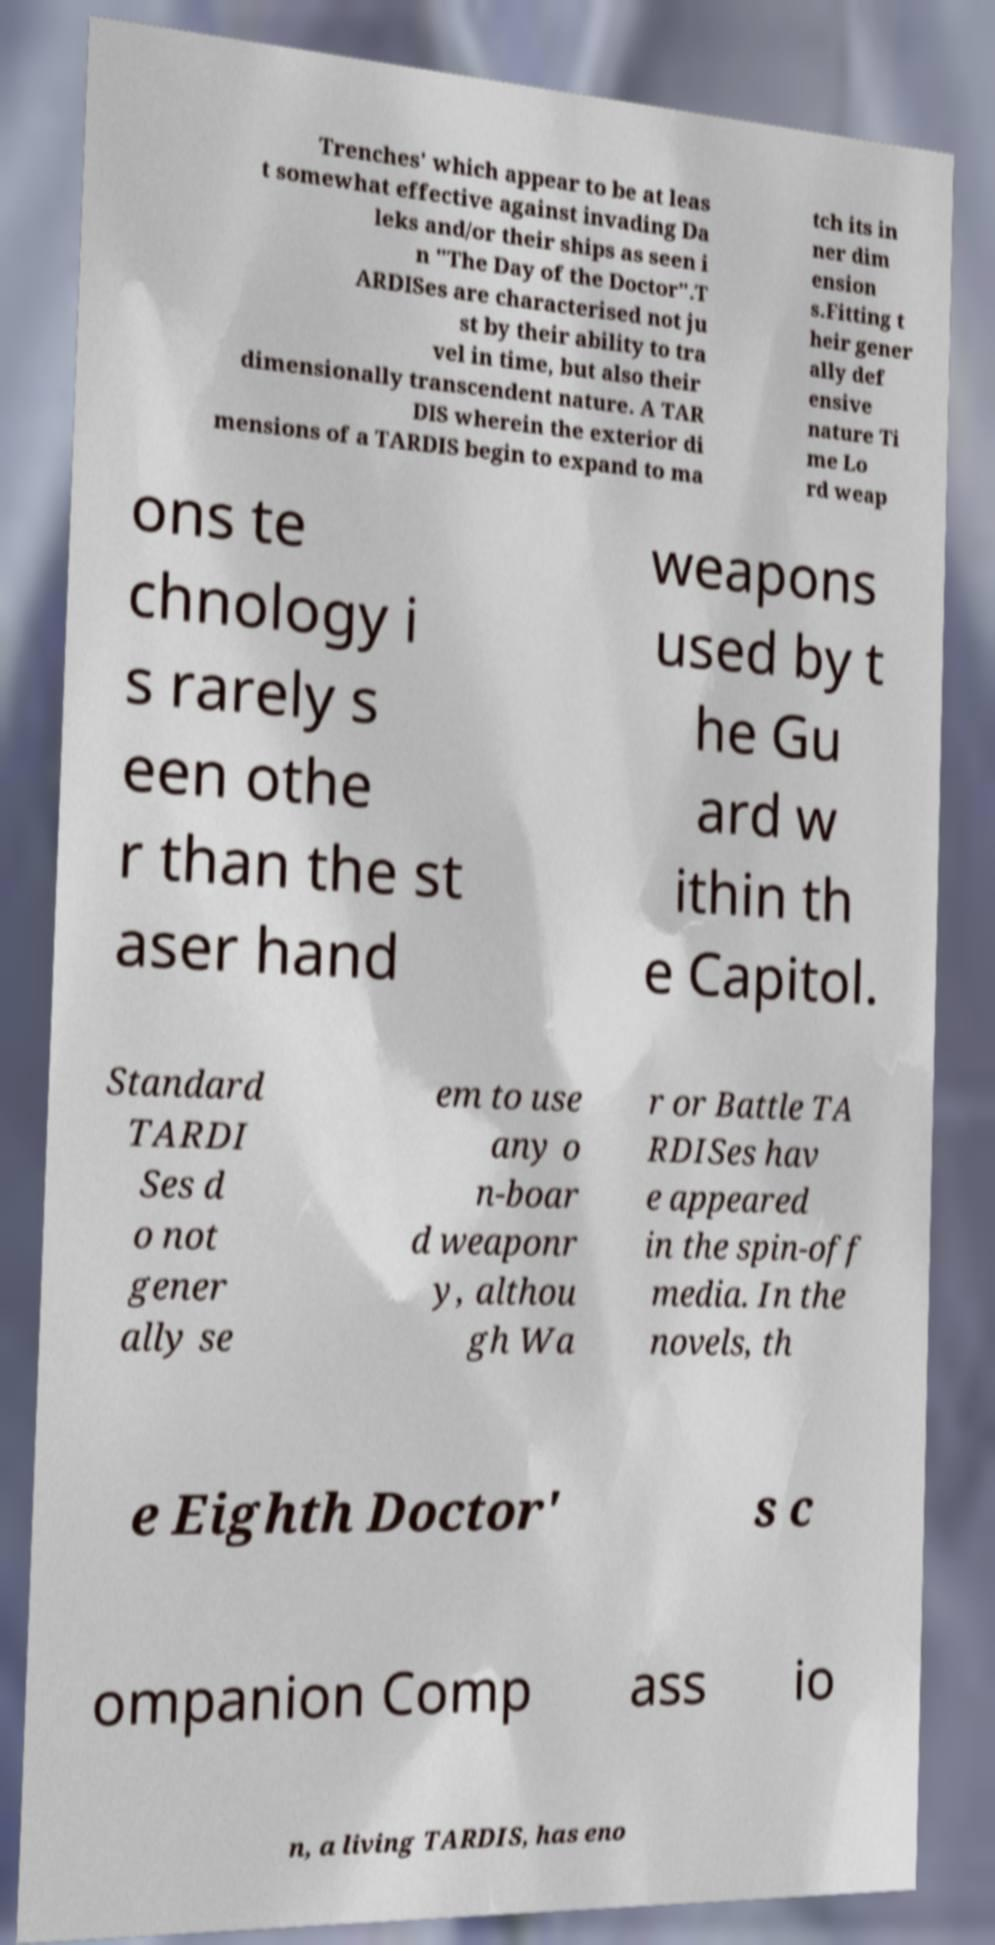Could you assist in decoding the text presented in this image and type it out clearly? Trenches' which appear to be at leas t somewhat effective against invading Da leks and/or their ships as seen i n "The Day of the Doctor".T ARDISes are characterised not ju st by their ability to tra vel in time, but also their dimensionally transcendent nature. A TAR DIS wherein the exterior di mensions of a TARDIS begin to expand to ma tch its in ner dim ension s.Fitting t heir gener ally def ensive nature Ti me Lo rd weap ons te chnology i s rarely s een othe r than the st aser hand weapons used by t he Gu ard w ithin th e Capitol. Standard TARDI Ses d o not gener ally se em to use any o n-boar d weaponr y, althou gh Wa r or Battle TA RDISes hav e appeared in the spin-off media. In the novels, th e Eighth Doctor' s c ompanion Comp ass io n, a living TARDIS, has eno 